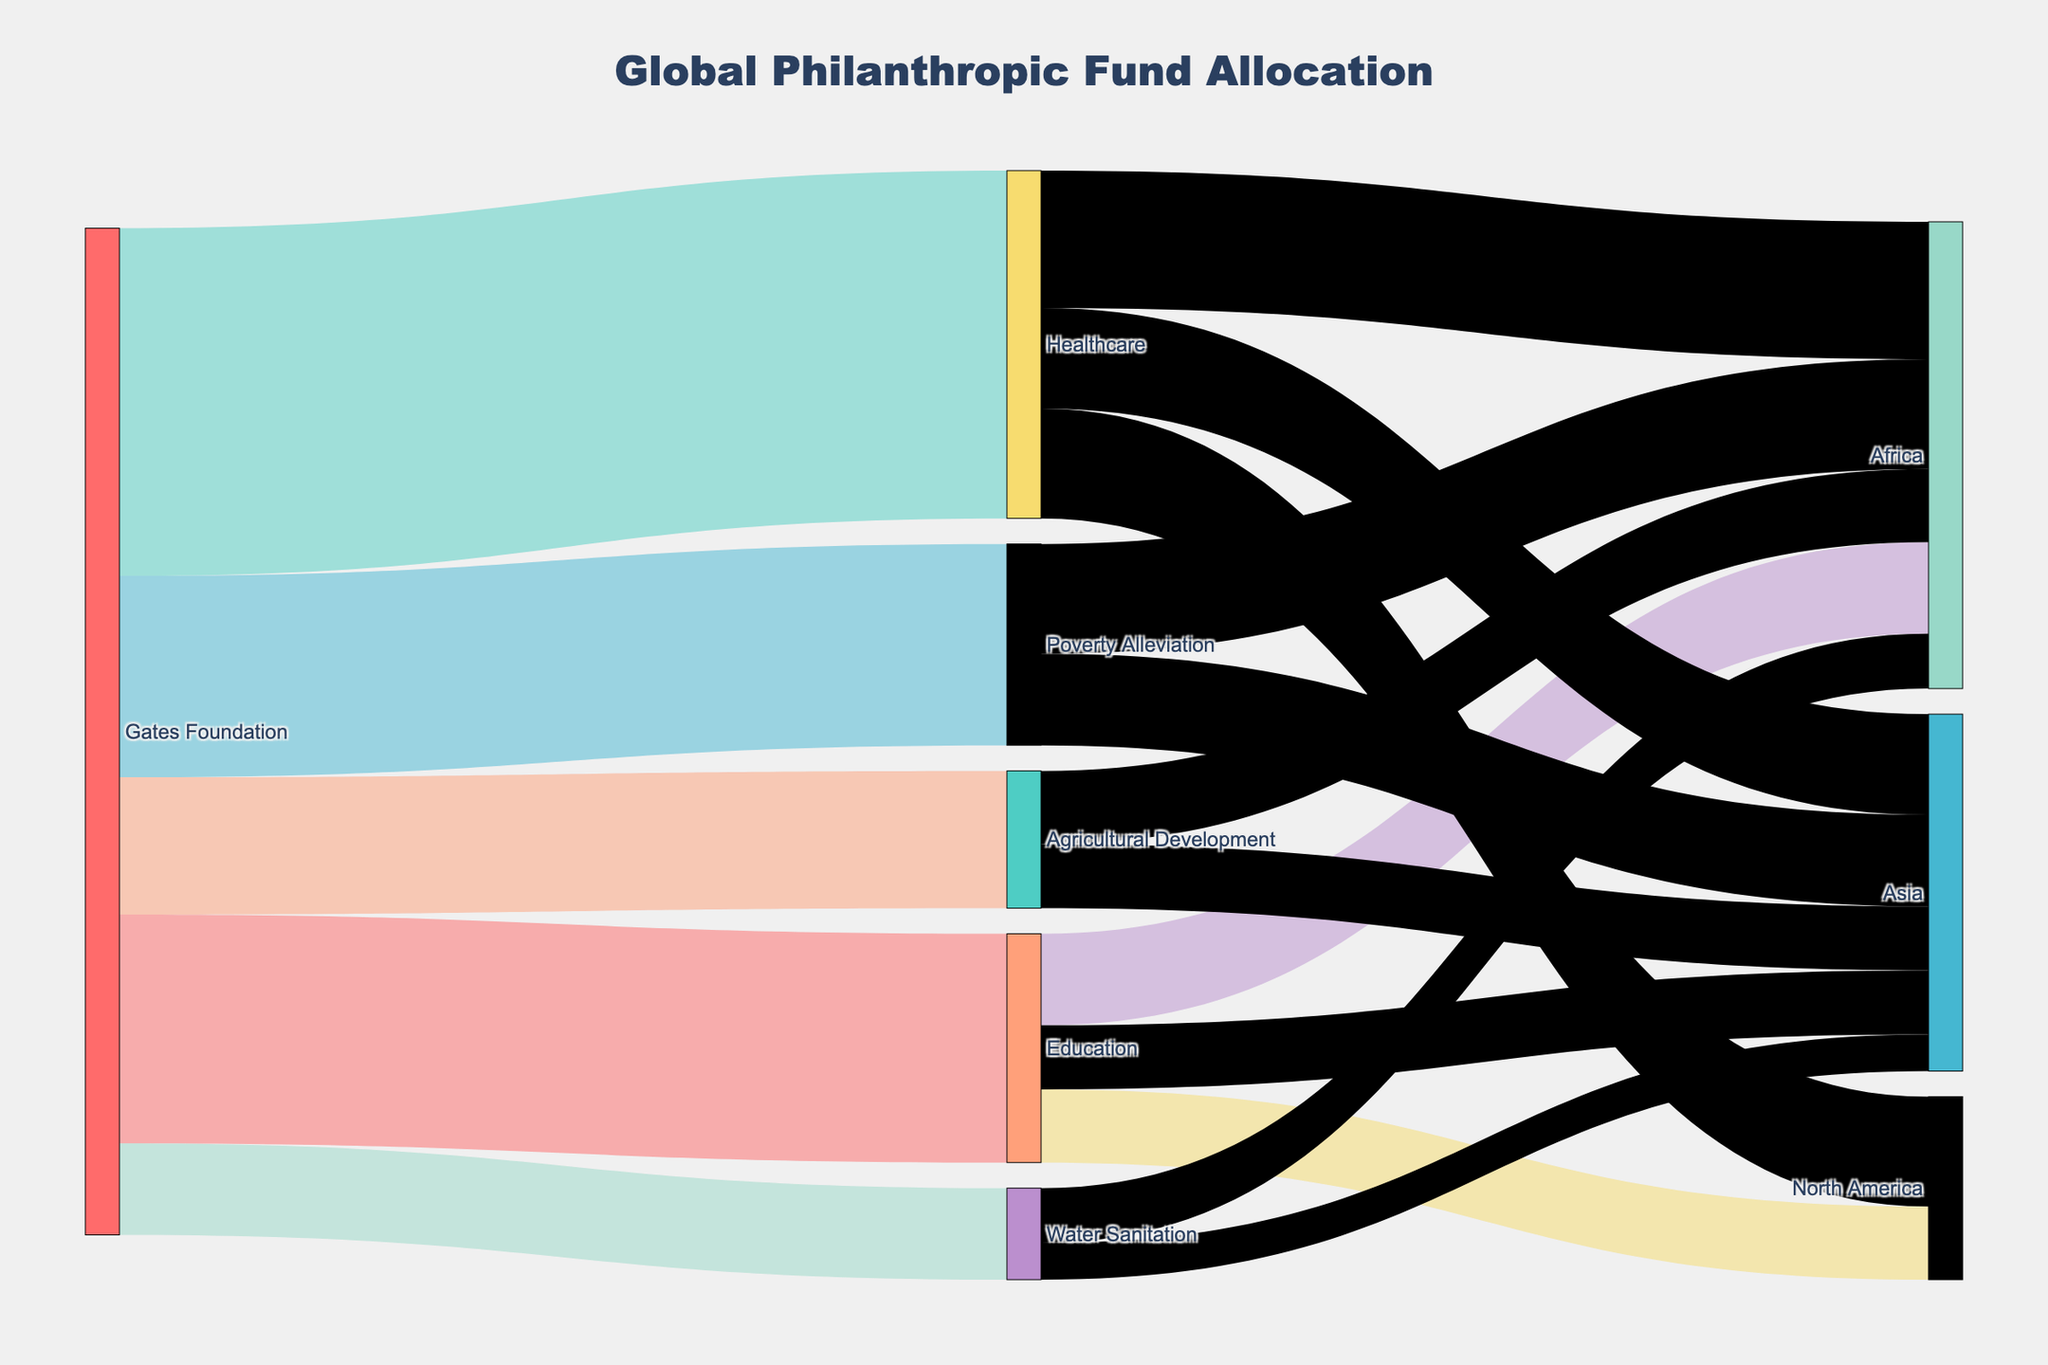What is the largest allocation of funds from the Gates Foundation to a specific cause? The largest allocation can be identified by looking at the value of each link from the Gates Foundation node. The Healthcare cause has the highest value of $3800.
Answer: $3800 Which cause received the least funding from the Gates Foundation? The cause with the smallest value linked from the Gates Foundation node represents the least funding. Water Sanitation received $1000, which is the smallest amount among the causes.
Answer: Water Sanitation How much total funding is allocated to the Education cause across all regions? To find the total, add the values allocated to North America, Africa, and Asia under the Education cause: $800 + $1000 + $700.
Answer: $2500 What is the difference in funding between Healthcare and Poverty Alleviation? Subtract the value of Poverty Alleviation from Healthcare: $3800 - $2200.
Answer: $1600 Which region receives the most funding for Healthcare? The region receiving the most funding can be identified by comparing the values linked to the Healthcare node. Africa receives $1500.
Answer: Africa What is the average funding allocated to Agricultural Development in the African and Asian regions? Add the values for Agricultural Development in Africa and Asia, then divide by 2: ($800 + $700) / 2.
Answer: $750 Compare the total funding allocations for Education and Water Sanitation. Which is higher? First, add the individual values for each cause. Education total is $2500, Water Sanitation total is $1000. Education's total is higher.
Answer: Education Which cause has the highest total funding in Asia? Compare the values for each cause linked to the Asia region. Healthcare has the highest value at $1100.
Answer: Healthcare How does the total funding for North America compare to that for Africa? Calculate the total funding for each region by summing the values for all causes. North America: $800 (Education) + $1200 (Healthcare) = $2000. Africa: $1000 (Education) + $1500 (Healthcare) + $1200 (Poverty Alleviation) + $800 (Agricultural Development) + $600 (Water Sanitation) = $5100. Africa's total is higher than North America's.
Answer: Africa is higher Which cause in North America receives more funding, Education or Healthcare? Compare the values linked to North America under the Education and Healthcare causes. Education receives $800, while Healthcare receives $1200, meaning Healthcare receives more funding.
Answer: Healthcare 